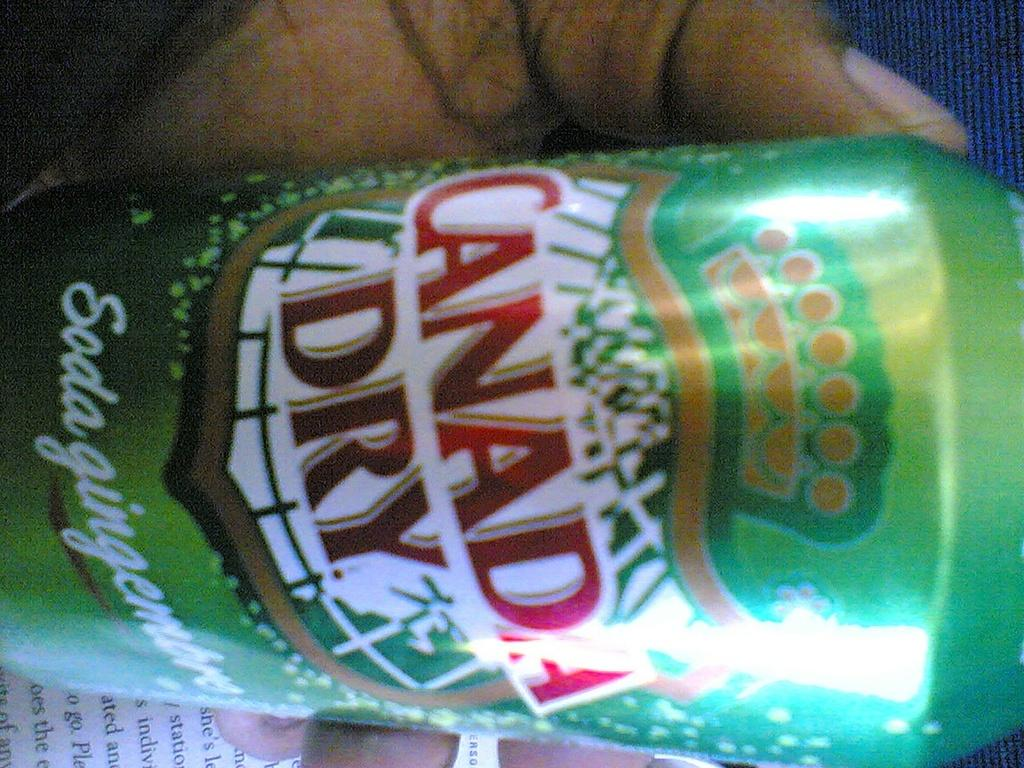<image>
Write a terse but informative summary of the picture. Someone is holding a can of canada dry soda 